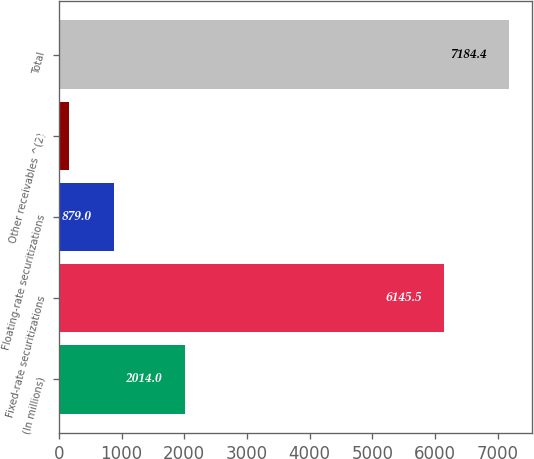Convert chart to OTSL. <chart><loc_0><loc_0><loc_500><loc_500><bar_chart><fcel>(In millions)<fcel>Fixed-rate securitizations<fcel>Floating-rate securitizations<fcel>Other receivables ^(2)<fcel>Total<nl><fcel>2014<fcel>6145.5<fcel>879<fcel>159.9<fcel>7184.4<nl></chart> 